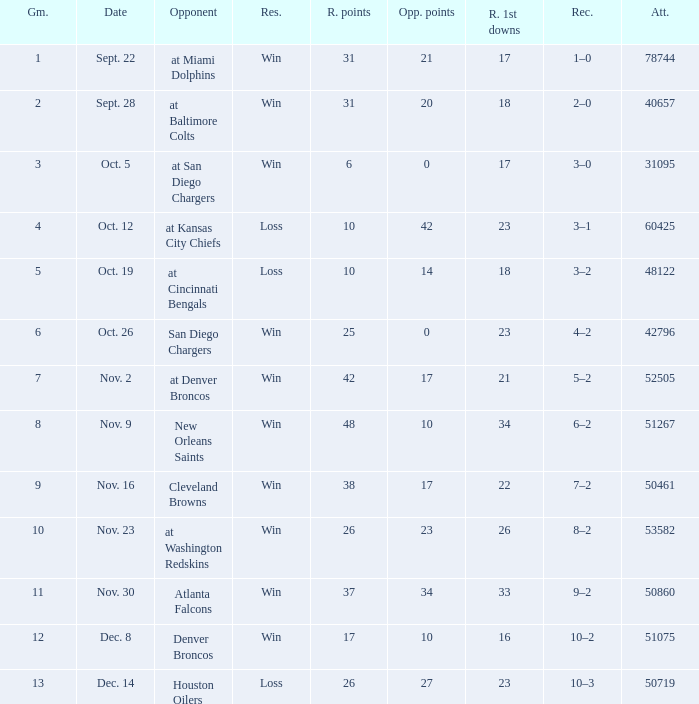How many opponents played 1 game with a result win? 21.0. 